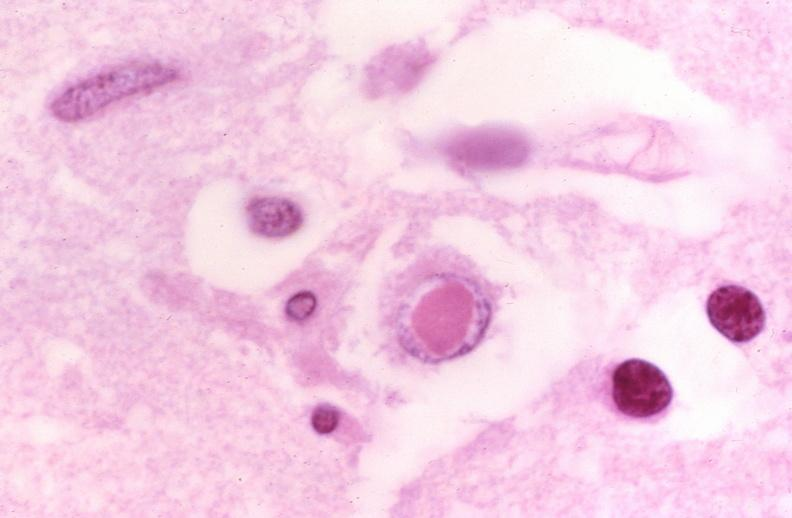does hemorrhage newborn show brain, herpes inclusion bodies?
Answer the question using a single word or phrase. No 